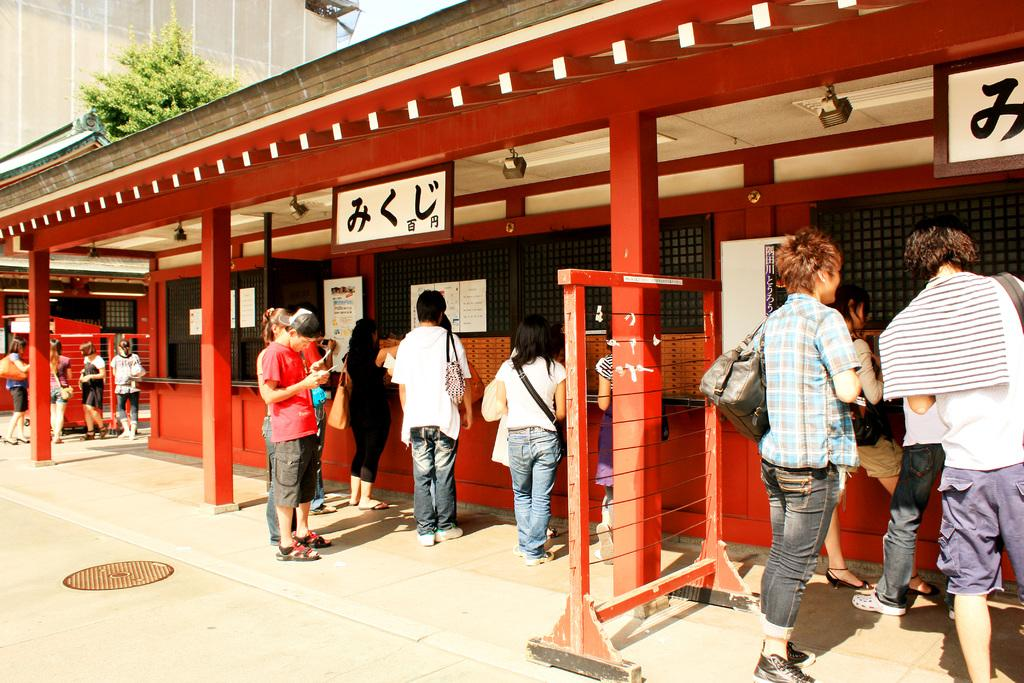What can be seen in the image involving people? There are people standing in the image. What type of structure is present with boards in the image? There is a building with boards in the image. What natural element is on the left side of the image? There is a tree on the left side of the image. What type of metal is the vest worn by the laborer in the image? There is no laborer or vest present in the image. What type of laborer can be seen working on the building in the image? There are no laborers or any indication of work being done on the building in the image. 